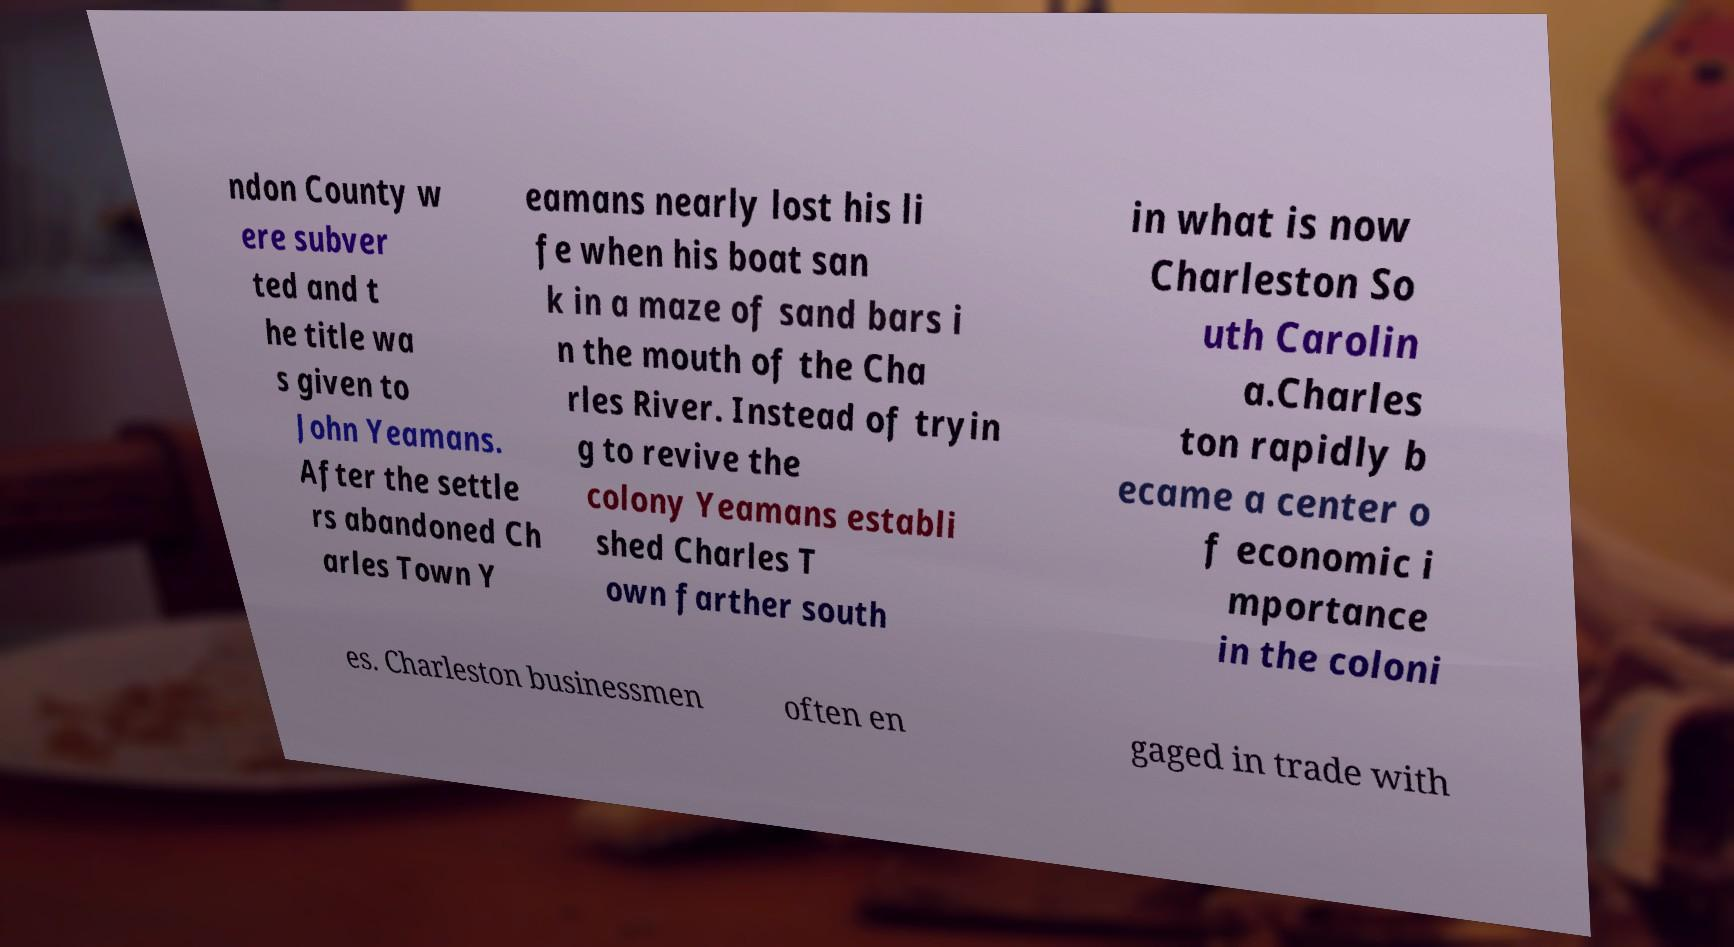Could you assist in decoding the text presented in this image and type it out clearly? ndon County w ere subver ted and t he title wa s given to John Yeamans. After the settle rs abandoned Ch arles Town Y eamans nearly lost his li fe when his boat san k in a maze of sand bars i n the mouth of the Cha rles River. Instead of tryin g to revive the colony Yeamans establi shed Charles T own farther south in what is now Charleston So uth Carolin a.Charles ton rapidly b ecame a center o f economic i mportance in the coloni es. Charleston businessmen often en gaged in trade with 